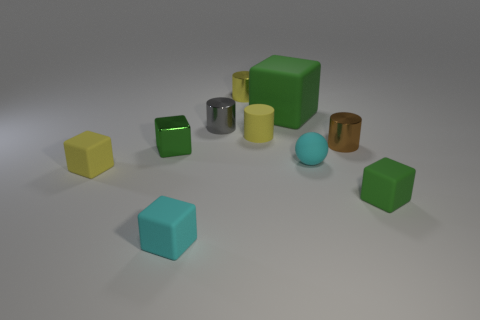Are there any spheres of the same color as the large cube?
Make the answer very short. No. There is a block that is behind the brown thing; is it the same size as the tiny gray thing?
Keep it short and to the point. No. What shape is the object that is both to the left of the matte cylinder and behind the tiny gray thing?
Offer a very short reply. Cylinder. Are there any small matte spheres to the right of the tiny yellow matte cylinder?
Your response must be concise. Yes. Are there any other things that have the same shape as the tiny yellow metallic thing?
Keep it short and to the point. Yes. Is the shape of the small gray shiny thing the same as the tiny brown thing?
Your answer should be very brief. Yes. Is the number of tiny gray things that are in front of the tiny brown metal object the same as the number of green blocks in front of the small yellow shiny cylinder?
Provide a short and direct response. No. What number of other things are made of the same material as the small brown object?
Keep it short and to the point. 3. What number of tiny things are either yellow rubber cubes or metal blocks?
Ensure brevity in your answer.  2. Is the number of rubber spheres that are in front of the tiny sphere the same as the number of tiny purple matte objects?
Your answer should be compact. Yes. 